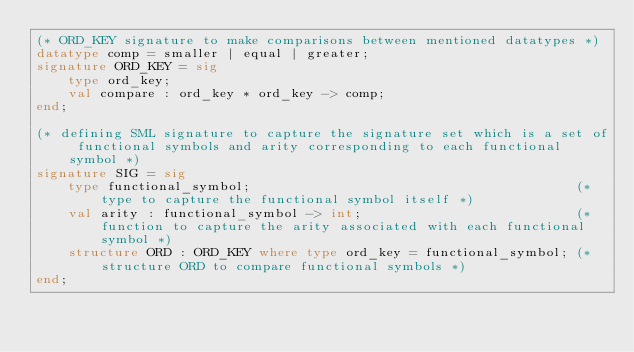<code> <loc_0><loc_0><loc_500><loc_500><_SML_>(* ORD_KEY signature to make comparisons between mentioned datatypes *)
datatype comp = smaller | equal | greater;
signature ORD_KEY = sig
    type ord_key;
    val compare : ord_key * ord_key -> comp;
end;

(* defining SML signature to capture the signature set which is a set of functional symbols and arity corresponding to each functional symbol *)
signature SIG = sig
    type functional_symbol;                                         (* type to capture the functional symbol itself *)
    val arity : functional_symbol -> int;                           (* function to capture the arity associated with each functional symbol *)
    structure ORD : ORD_KEY where type ord_key = functional_symbol; (* structure ORD to compare functional symbols *)
end;
</code> 